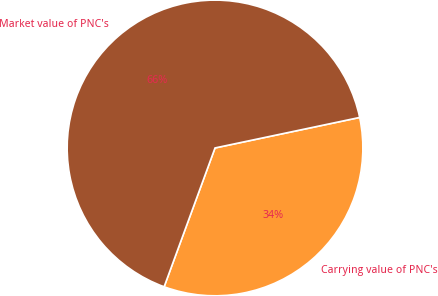<chart> <loc_0><loc_0><loc_500><loc_500><pie_chart><fcel>Carrying value of PNC's<fcel>Market value of PNC's<nl><fcel>33.9%<fcel>66.1%<nl></chart> 